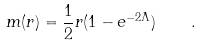Convert formula to latex. <formula><loc_0><loc_0><loc_500><loc_500>m ( r ) = \frac { 1 } { 2 } r ( 1 - e ^ { - 2 \Lambda } ) \quad .</formula> 